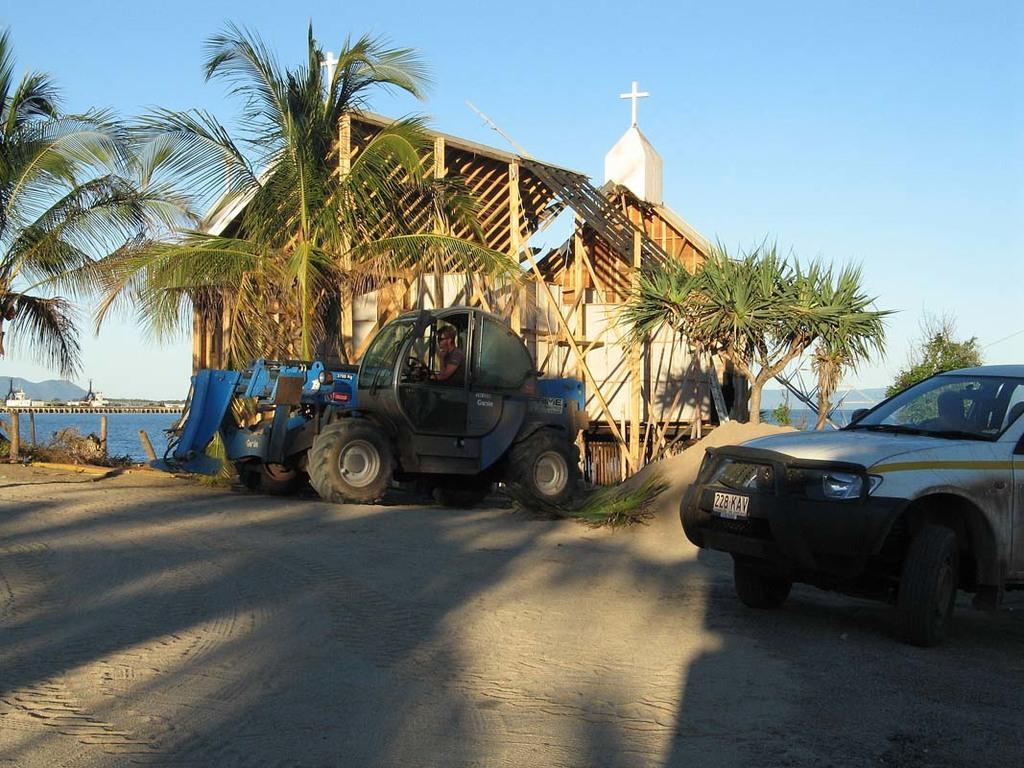Can you describe this image briefly? In the foreground of the picture there are sand and vehicles. In the center of the picture there are palm trees, church, trees and other objects. In the background there are hills and a water body. 